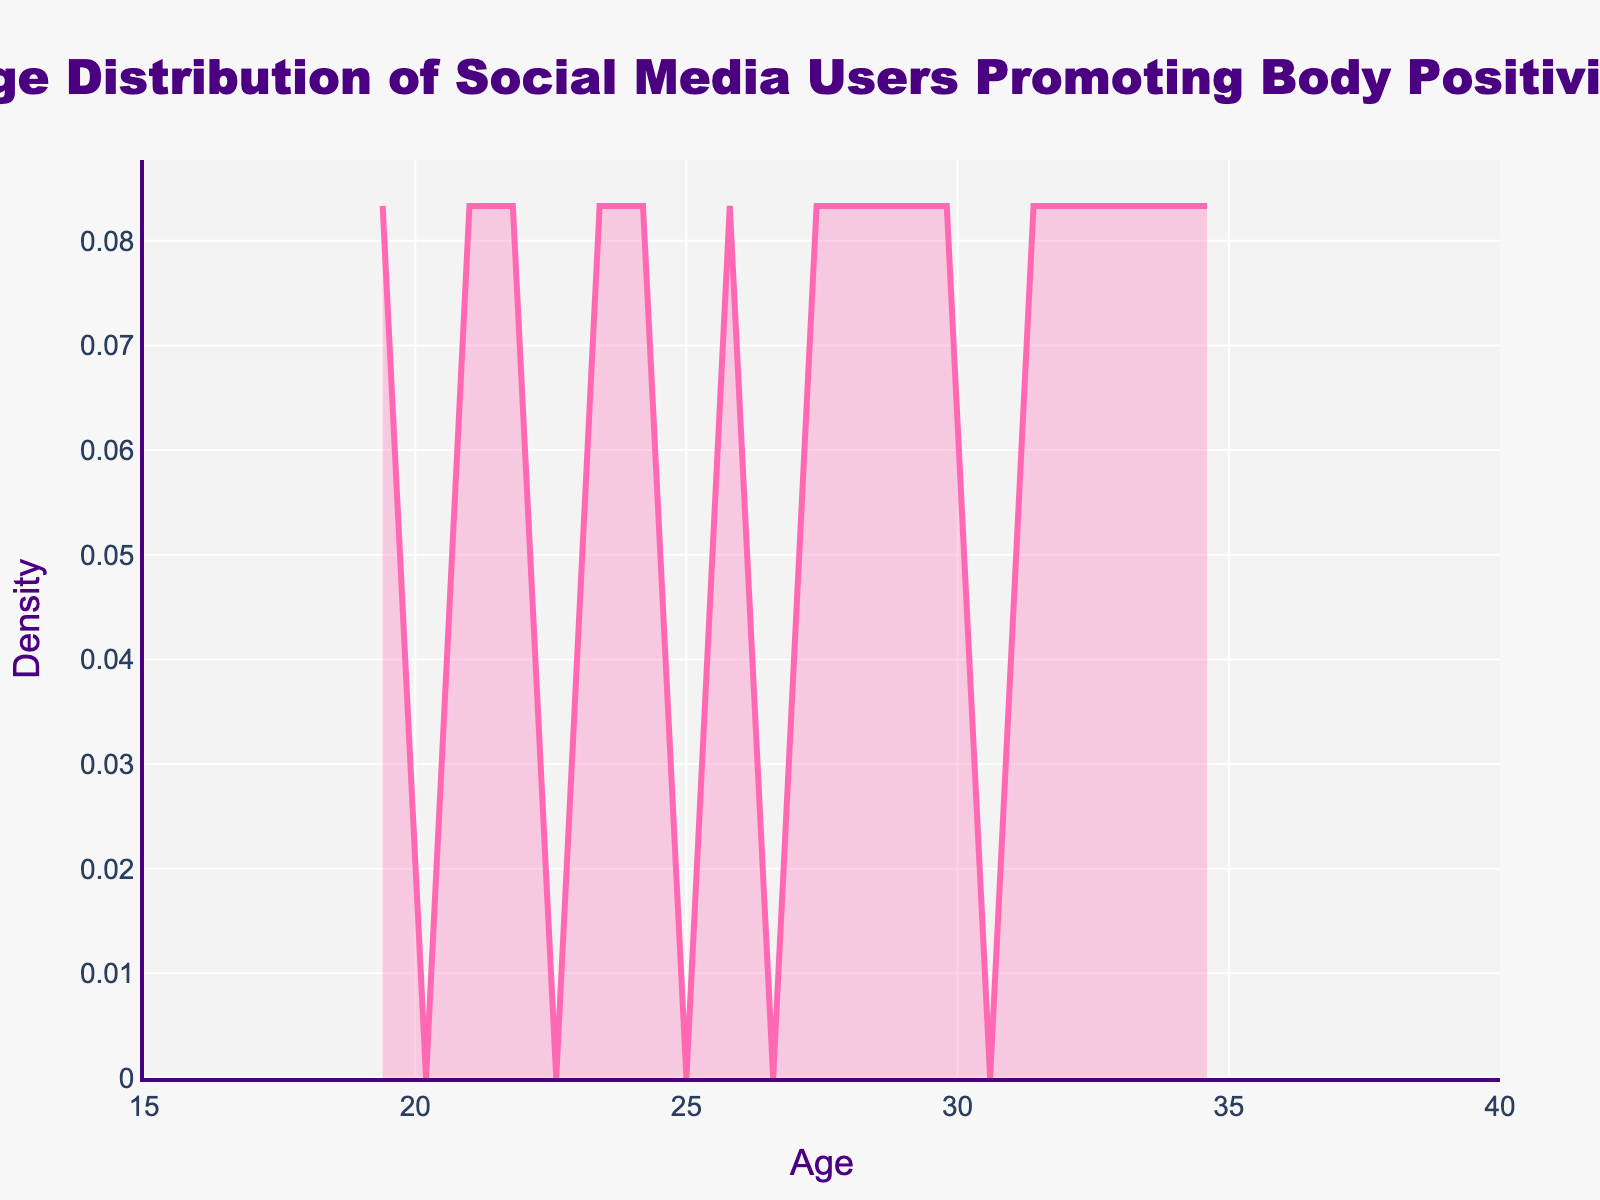What's the title of the figure? The title of the figure is positioned centrally at the top and it reads "Age Distribution of Social Media Users Promoting Body Positivity."
Answer: Age Distribution of Social Media Users Promoting Body Positivity What is the range of the x-axis? The x-axis spans from the minimal value that is marked as 15 to the maximum value marked as 40, as indicated by the horizontal axis labels.
Answer: 15 to 40 What color is used to fill the density plot? The fill color for the density plot is a light pink shade with semi-transparency, creating a visually distinct filled area under the line.
Answer: Light pink What is the maximum height of the density plot? The maximum height of the density plot can be roughly estimated from the peak of the density curve on the y-axis. By observing, it appears to be near the value of 0.06.
Answer: Approximately 0.06 At what age does the density plot appear to peak? The density plot reaches its maximum height at around the age where the x-axis value aligns with the highest point of the curve. This age is approximately 28 years old.
Answer: Approximately 28 years old How does the density at age 30 compare to the density at age 22? To compare, you look at the height of the density curve at both ages. The density at age 30 is somewhat lower compared to the density at age 22, as indicated by the lower height of the curve at age 30 relative to age 22.
Answer: Density is lower at age 30 than at age 22 What is the general shape of the density curve? The density curve generally forms a single, smooth peak around age 28, tapering off symmetrically on both sides as it approaches the minimum and maximum ages in the range.
Answer: Single peak around age 28, tapering symmetrically Can you identify a specific age range where the density is relatively high? The density remains relatively high between the ages of 20 and 35, as the curve stays elevated within this range. This indicates a higher concentration of users within these ages.
Answer: 20 to 35 What does the y-axis represent in the context of this plot? The y-axis represents "Density," which indicates the distribution of social media users across different ages, showing the relative number of users at each age interval.
Answer: Density Is there any value on the x-axis where the density curve begins and ends? The density curve begins at an age slightly above 15 and ends just before 40, which are the boundary values of the x-axis.
Answer: Slightly above 15 and just before 40 